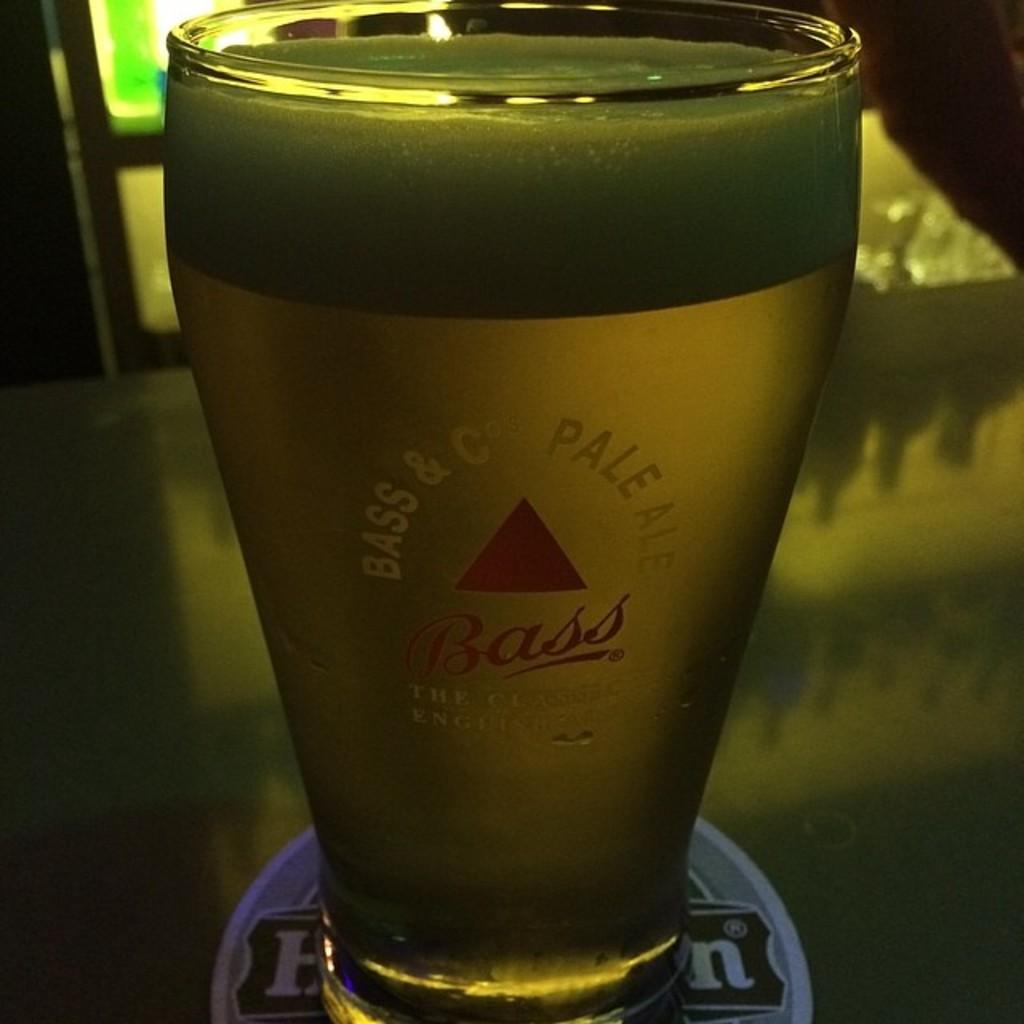<image>
Summarize the visual content of the image. A glass from a company called Bass &C is on a table 